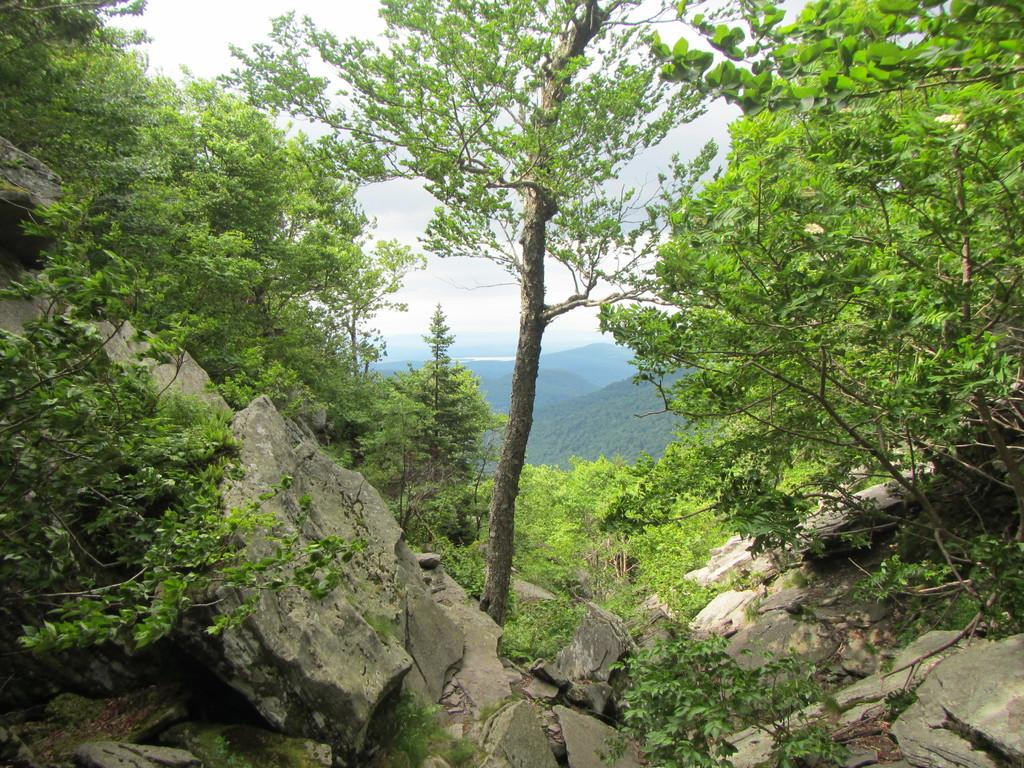What type of natural elements can be seen in the image? There are rocks, trees, and hills visible in the image. What is the background of the image? The sky is visible in the background of the image. How many jelly containers can be seen on the plantation in the image? There is no plantation or jelly containers present in the image. What type of chairs are placed near the rocks in the image? There are no chairs present in the image. 